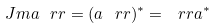<formula> <loc_0><loc_0><loc_500><loc_500>\ J m a \ r r = ( a \ r r ) ^ { * } = \ r r a ^ { * }</formula> 